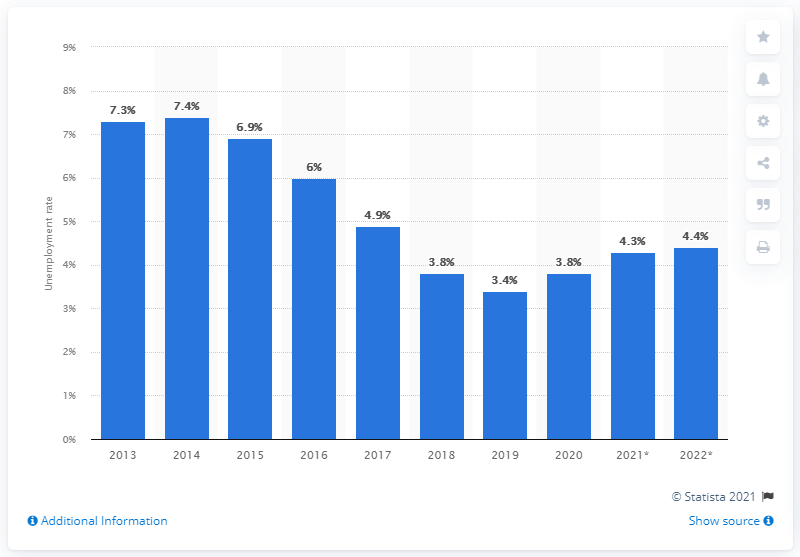Draw attention to some important aspects in this diagram. The unemployment rate is expected to increase to 4.4% by 2022, according to projections. 